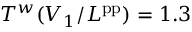<formula> <loc_0><loc_0><loc_500><loc_500>T ^ { w } ( V _ { 1 } / L ^ { p p } ) = 1 . 3</formula> 